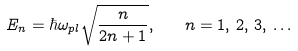Convert formula to latex. <formula><loc_0><loc_0><loc_500><loc_500>E _ { n } = \hbar { \omega } _ { p l } \sqrt { \frac { n } { 2 n + 1 } } , \quad n = 1 , \, 2 , \, 3 , \, \dots</formula> 